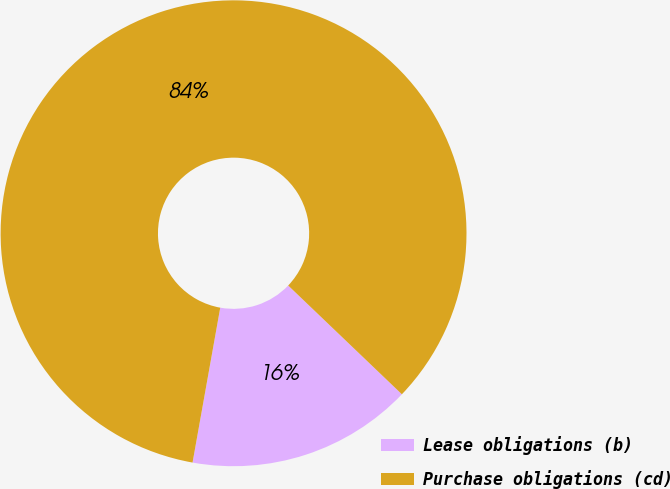Convert chart. <chart><loc_0><loc_0><loc_500><loc_500><pie_chart><fcel>Lease obligations (b)<fcel>Purchase obligations (cd)<nl><fcel>15.67%<fcel>84.33%<nl></chart> 